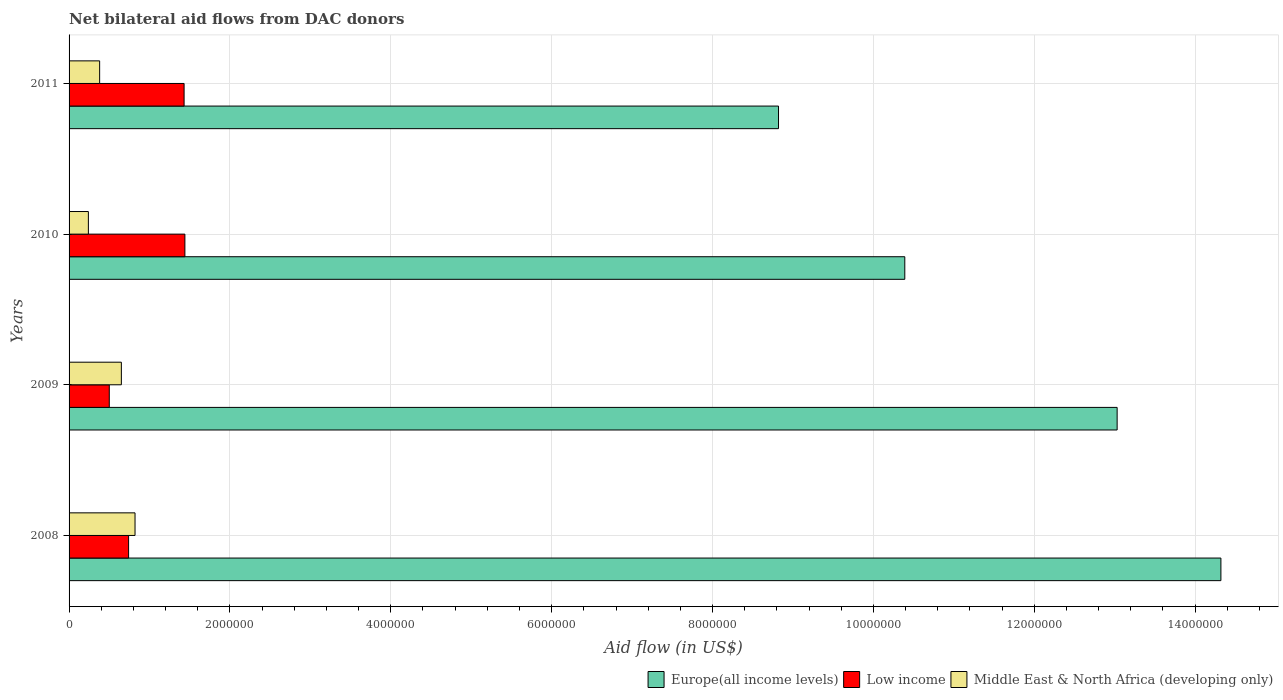How many different coloured bars are there?
Offer a very short reply. 3. How many bars are there on the 4th tick from the top?
Offer a terse response. 3. In how many cases, is the number of bars for a given year not equal to the number of legend labels?
Provide a short and direct response. 0. What is the net bilateral aid flow in Middle East & North Africa (developing only) in 2011?
Your answer should be very brief. 3.80e+05. Across all years, what is the maximum net bilateral aid flow in Middle East & North Africa (developing only)?
Ensure brevity in your answer.  8.20e+05. Across all years, what is the minimum net bilateral aid flow in Low income?
Ensure brevity in your answer.  5.00e+05. In which year was the net bilateral aid flow in Europe(all income levels) maximum?
Your answer should be very brief. 2008. What is the total net bilateral aid flow in Middle East & North Africa (developing only) in the graph?
Give a very brief answer. 2.09e+06. What is the difference between the net bilateral aid flow in Middle East & North Africa (developing only) in 2010 and that in 2011?
Your response must be concise. -1.40e+05. What is the difference between the net bilateral aid flow in Low income in 2010 and the net bilateral aid flow in Middle East & North Africa (developing only) in 2009?
Offer a very short reply. 7.90e+05. What is the average net bilateral aid flow in Middle East & North Africa (developing only) per year?
Offer a very short reply. 5.22e+05. In the year 2009, what is the difference between the net bilateral aid flow in Low income and net bilateral aid flow in Europe(all income levels)?
Provide a succinct answer. -1.25e+07. In how many years, is the net bilateral aid flow in Middle East & North Africa (developing only) greater than 1200000 US$?
Provide a short and direct response. 0. What is the ratio of the net bilateral aid flow in Low income in 2009 to that in 2011?
Offer a very short reply. 0.35. Is the difference between the net bilateral aid flow in Low income in 2008 and 2011 greater than the difference between the net bilateral aid flow in Europe(all income levels) in 2008 and 2011?
Your answer should be very brief. No. What is the difference between the highest and the lowest net bilateral aid flow in Middle East & North Africa (developing only)?
Provide a short and direct response. 5.80e+05. Is the sum of the net bilateral aid flow in Middle East & North Africa (developing only) in 2008 and 2011 greater than the maximum net bilateral aid flow in Low income across all years?
Keep it short and to the point. No. What does the 2nd bar from the top in 2011 represents?
Make the answer very short. Low income. What does the 1st bar from the bottom in 2009 represents?
Offer a very short reply. Europe(all income levels). Is it the case that in every year, the sum of the net bilateral aid flow in Middle East & North Africa (developing only) and net bilateral aid flow in Low income is greater than the net bilateral aid flow in Europe(all income levels)?
Your answer should be compact. No. How many bars are there?
Provide a short and direct response. 12. Are all the bars in the graph horizontal?
Your answer should be compact. Yes. How many years are there in the graph?
Offer a very short reply. 4. What is the difference between two consecutive major ticks on the X-axis?
Provide a succinct answer. 2.00e+06. Are the values on the major ticks of X-axis written in scientific E-notation?
Ensure brevity in your answer.  No. Does the graph contain any zero values?
Ensure brevity in your answer.  No. Does the graph contain grids?
Your response must be concise. Yes. Where does the legend appear in the graph?
Offer a terse response. Bottom right. How many legend labels are there?
Your answer should be very brief. 3. How are the legend labels stacked?
Your response must be concise. Horizontal. What is the title of the graph?
Give a very brief answer. Net bilateral aid flows from DAC donors. What is the label or title of the X-axis?
Give a very brief answer. Aid flow (in US$). What is the label or title of the Y-axis?
Provide a succinct answer. Years. What is the Aid flow (in US$) of Europe(all income levels) in 2008?
Your response must be concise. 1.43e+07. What is the Aid flow (in US$) of Low income in 2008?
Your answer should be very brief. 7.40e+05. What is the Aid flow (in US$) in Middle East & North Africa (developing only) in 2008?
Make the answer very short. 8.20e+05. What is the Aid flow (in US$) of Europe(all income levels) in 2009?
Your response must be concise. 1.30e+07. What is the Aid flow (in US$) of Low income in 2009?
Offer a terse response. 5.00e+05. What is the Aid flow (in US$) in Middle East & North Africa (developing only) in 2009?
Your answer should be very brief. 6.50e+05. What is the Aid flow (in US$) of Europe(all income levels) in 2010?
Offer a very short reply. 1.04e+07. What is the Aid flow (in US$) in Low income in 2010?
Provide a succinct answer. 1.44e+06. What is the Aid flow (in US$) of Middle East & North Africa (developing only) in 2010?
Provide a succinct answer. 2.40e+05. What is the Aid flow (in US$) in Europe(all income levels) in 2011?
Your answer should be compact. 8.82e+06. What is the Aid flow (in US$) in Low income in 2011?
Ensure brevity in your answer.  1.43e+06. Across all years, what is the maximum Aid flow (in US$) in Europe(all income levels)?
Offer a very short reply. 1.43e+07. Across all years, what is the maximum Aid flow (in US$) of Low income?
Make the answer very short. 1.44e+06. Across all years, what is the maximum Aid flow (in US$) in Middle East & North Africa (developing only)?
Offer a terse response. 8.20e+05. Across all years, what is the minimum Aid flow (in US$) in Europe(all income levels)?
Ensure brevity in your answer.  8.82e+06. Across all years, what is the minimum Aid flow (in US$) of Low income?
Your answer should be compact. 5.00e+05. Across all years, what is the minimum Aid flow (in US$) of Middle East & North Africa (developing only)?
Offer a very short reply. 2.40e+05. What is the total Aid flow (in US$) of Europe(all income levels) in the graph?
Offer a very short reply. 4.66e+07. What is the total Aid flow (in US$) in Low income in the graph?
Your answer should be compact. 4.11e+06. What is the total Aid flow (in US$) in Middle East & North Africa (developing only) in the graph?
Offer a very short reply. 2.09e+06. What is the difference between the Aid flow (in US$) of Europe(all income levels) in 2008 and that in 2009?
Your response must be concise. 1.29e+06. What is the difference between the Aid flow (in US$) of Low income in 2008 and that in 2009?
Make the answer very short. 2.40e+05. What is the difference between the Aid flow (in US$) in Europe(all income levels) in 2008 and that in 2010?
Your answer should be compact. 3.93e+06. What is the difference between the Aid flow (in US$) in Low income in 2008 and that in 2010?
Provide a succinct answer. -7.00e+05. What is the difference between the Aid flow (in US$) of Middle East & North Africa (developing only) in 2008 and that in 2010?
Offer a terse response. 5.80e+05. What is the difference between the Aid flow (in US$) of Europe(all income levels) in 2008 and that in 2011?
Your answer should be very brief. 5.50e+06. What is the difference between the Aid flow (in US$) of Low income in 2008 and that in 2011?
Offer a terse response. -6.90e+05. What is the difference between the Aid flow (in US$) of Europe(all income levels) in 2009 and that in 2010?
Provide a succinct answer. 2.64e+06. What is the difference between the Aid flow (in US$) in Low income in 2009 and that in 2010?
Give a very brief answer. -9.40e+05. What is the difference between the Aid flow (in US$) in Middle East & North Africa (developing only) in 2009 and that in 2010?
Make the answer very short. 4.10e+05. What is the difference between the Aid flow (in US$) of Europe(all income levels) in 2009 and that in 2011?
Offer a very short reply. 4.21e+06. What is the difference between the Aid flow (in US$) in Low income in 2009 and that in 2011?
Your response must be concise. -9.30e+05. What is the difference between the Aid flow (in US$) in Europe(all income levels) in 2010 and that in 2011?
Give a very brief answer. 1.57e+06. What is the difference between the Aid flow (in US$) of Europe(all income levels) in 2008 and the Aid flow (in US$) of Low income in 2009?
Offer a very short reply. 1.38e+07. What is the difference between the Aid flow (in US$) of Europe(all income levels) in 2008 and the Aid flow (in US$) of Middle East & North Africa (developing only) in 2009?
Offer a terse response. 1.37e+07. What is the difference between the Aid flow (in US$) of Low income in 2008 and the Aid flow (in US$) of Middle East & North Africa (developing only) in 2009?
Offer a terse response. 9.00e+04. What is the difference between the Aid flow (in US$) in Europe(all income levels) in 2008 and the Aid flow (in US$) in Low income in 2010?
Make the answer very short. 1.29e+07. What is the difference between the Aid flow (in US$) in Europe(all income levels) in 2008 and the Aid flow (in US$) in Middle East & North Africa (developing only) in 2010?
Make the answer very short. 1.41e+07. What is the difference between the Aid flow (in US$) in Europe(all income levels) in 2008 and the Aid flow (in US$) in Low income in 2011?
Ensure brevity in your answer.  1.29e+07. What is the difference between the Aid flow (in US$) of Europe(all income levels) in 2008 and the Aid flow (in US$) of Middle East & North Africa (developing only) in 2011?
Give a very brief answer. 1.39e+07. What is the difference between the Aid flow (in US$) of Europe(all income levels) in 2009 and the Aid flow (in US$) of Low income in 2010?
Provide a succinct answer. 1.16e+07. What is the difference between the Aid flow (in US$) in Europe(all income levels) in 2009 and the Aid flow (in US$) in Middle East & North Africa (developing only) in 2010?
Offer a very short reply. 1.28e+07. What is the difference between the Aid flow (in US$) of Europe(all income levels) in 2009 and the Aid flow (in US$) of Low income in 2011?
Offer a terse response. 1.16e+07. What is the difference between the Aid flow (in US$) in Europe(all income levels) in 2009 and the Aid flow (in US$) in Middle East & North Africa (developing only) in 2011?
Your response must be concise. 1.26e+07. What is the difference between the Aid flow (in US$) of Europe(all income levels) in 2010 and the Aid flow (in US$) of Low income in 2011?
Give a very brief answer. 8.96e+06. What is the difference between the Aid flow (in US$) of Europe(all income levels) in 2010 and the Aid flow (in US$) of Middle East & North Africa (developing only) in 2011?
Make the answer very short. 1.00e+07. What is the difference between the Aid flow (in US$) in Low income in 2010 and the Aid flow (in US$) in Middle East & North Africa (developing only) in 2011?
Offer a terse response. 1.06e+06. What is the average Aid flow (in US$) in Europe(all income levels) per year?
Keep it short and to the point. 1.16e+07. What is the average Aid flow (in US$) in Low income per year?
Your answer should be compact. 1.03e+06. What is the average Aid flow (in US$) of Middle East & North Africa (developing only) per year?
Your response must be concise. 5.22e+05. In the year 2008, what is the difference between the Aid flow (in US$) of Europe(all income levels) and Aid flow (in US$) of Low income?
Offer a terse response. 1.36e+07. In the year 2008, what is the difference between the Aid flow (in US$) in Europe(all income levels) and Aid flow (in US$) in Middle East & North Africa (developing only)?
Ensure brevity in your answer.  1.35e+07. In the year 2009, what is the difference between the Aid flow (in US$) in Europe(all income levels) and Aid flow (in US$) in Low income?
Provide a short and direct response. 1.25e+07. In the year 2009, what is the difference between the Aid flow (in US$) in Europe(all income levels) and Aid flow (in US$) in Middle East & North Africa (developing only)?
Your answer should be very brief. 1.24e+07. In the year 2010, what is the difference between the Aid flow (in US$) of Europe(all income levels) and Aid flow (in US$) of Low income?
Provide a succinct answer. 8.95e+06. In the year 2010, what is the difference between the Aid flow (in US$) in Europe(all income levels) and Aid flow (in US$) in Middle East & North Africa (developing only)?
Provide a succinct answer. 1.02e+07. In the year 2010, what is the difference between the Aid flow (in US$) in Low income and Aid flow (in US$) in Middle East & North Africa (developing only)?
Your response must be concise. 1.20e+06. In the year 2011, what is the difference between the Aid flow (in US$) of Europe(all income levels) and Aid flow (in US$) of Low income?
Ensure brevity in your answer.  7.39e+06. In the year 2011, what is the difference between the Aid flow (in US$) in Europe(all income levels) and Aid flow (in US$) in Middle East & North Africa (developing only)?
Make the answer very short. 8.44e+06. In the year 2011, what is the difference between the Aid flow (in US$) of Low income and Aid flow (in US$) of Middle East & North Africa (developing only)?
Make the answer very short. 1.05e+06. What is the ratio of the Aid flow (in US$) of Europe(all income levels) in 2008 to that in 2009?
Provide a short and direct response. 1.1. What is the ratio of the Aid flow (in US$) of Low income in 2008 to that in 2009?
Provide a succinct answer. 1.48. What is the ratio of the Aid flow (in US$) of Middle East & North Africa (developing only) in 2008 to that in 2009?
Provide a short and direct response. 1.26. What is the ratio of the Aid flow (in US$) of Europe(all income levels) in 2008 to that in 2010?
Your answer should be very brief. 1.38. What is the ratio of the Aid flow (in US$) of Low income in 2008 to that in 2010?
Give a very brief answer. 0.51. What is the ratio of the Aid flow (in US$) in Middle East & North Africa (developing only) in 2008 to that in 2010?
Offer a terse response. 3.42. What is the ratio of the Aid flow (in US$) in Europe(all income levels) in 2008 to that in 2011?
Provide a short and direct response. 1.62. What is the ratio of the Aid flow (in US$) of Low income in 2008 to that in 2011?
Make the answer very short. 0.52. What is the ratio of the Aid flow (in US$) in Middle East & North Africa (developing only) in 2008 to that in 2011?
Offer a very short reply. 2.16. What is the ratio of the Aid flow (in US$) in Europe(all income levels) in 2009 to that in 2010?
Give a very brief answer. 1.25. What is the ratio of the Aid flow (in US$) of Low income in 2009 to that in 2010?
Your answer should be compact. 0.35. What is the ratio of the Aid flow (in US$) in Middle East & North Africa (developing only) in 2009 to that in 2010?
Your response must be concise. 2.71. What is the ratio of the Aid flow (in US$) in Europe(all income levels) in 2009 to that in 2011?
Provide a short and direct response. 1.48. What is the ratio of the Aid flow (in US$) in Low income in 2009 to that in 2011?
Keep it short and to the point. 0.35. What is the ratio of the Aid flow (in US$) in Middle East & North Africa (developing only) in 2009 to that in 2011?
Give a very brief answer. 1.71. What is the ratio of the Aid flow (in US$) in Europe(all income levels) in 2010 to that in 2011?
Your answer should be compact. 1.18. What is the ratio of the Aid flow (in US$) in Middle East & North Africa (developing only) in 2010 to that in 2011?
Keep it short and to the point. 0.63. What is the difference between the highest and the second highest Aid flow (in US$) of Europe(all income levels)?
Your answer should be very brief. 1.29e+06. What is the difference between the highest and the second highest Aid flow (in US$) of Low income?
Provide a short and direct response. 10000. What is the difference between the highest and the second highest Aid flow (in US$) of Middle East & North Africa (developing only)?
Give a very brief answer. 1.70e+05. What is the difference between the highest and the lowest Aid flow (in US$) in Europe(all income levels)?
Keep it short and to the point. 5.50e+06. What is the difference between the highest and the lowest Aid flow (in US$) in Low income?
Keep it short and to the point. 9.40e+05. What is the difference between the highest and the lowest Aid flow (in US$) of Middle East & North Africa (developing only)?
Provide a succinct answer. 5.80e+05. 